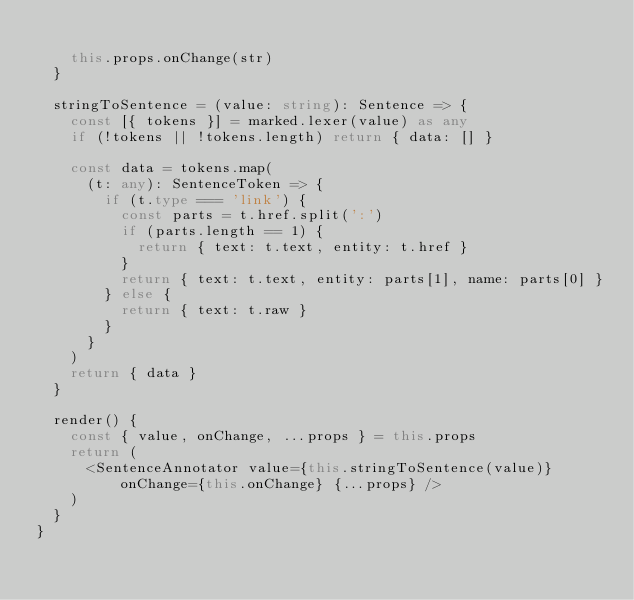Convert code to text. <code><loc_0><loc_0><loc_500><loc_500><_TypeScript_>
    this.props.onChange(str)
  }

  stringToSentence = (value: string): Sentence => {
    const [{ tokens }] = marked.lexer(value) as any
    if (!tokens || !tokens.length) return { data: [] }

    const data = tokens.map(
      (t: any): SentenceToken => {
        if (t.type === 'link') {
          const parts = t.href.split(':')
          if (parts.length == 1) {
            return { text: t.text, entity: t.href }
          }
          return { text: t.text, entity: parts[1], name: parts[0] }
        } else {
          return { text: t.raw }
        }
      }
    )
    return { data }
  }

  render() {
    const { value, onChange, ...props } = this.props
    return (
      <SentenceAnnotator value={this.stringToSentence(value)} onChange={this.onChange} {...props} />
    )
  }
}
</code> 